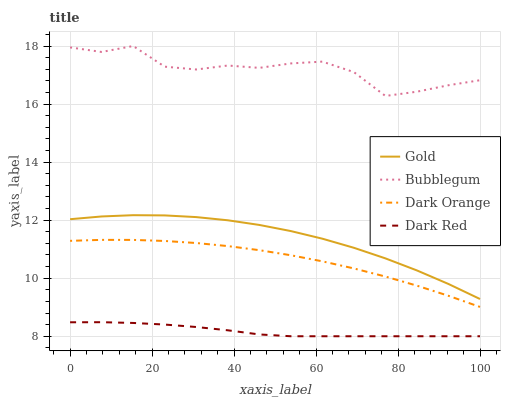Does Dark Red have the minimum area under the curve?
Answer yes or no. Yes. Does Bubblegum have the maximum area under the curve?
Answer yes or no. Yes. Does Gold have the minimum area under the curve?
Answer yes or no. No. Does Gold have the maximum area under the curve?
Answer yes or no. No. Is Dark Red the smoothest?
Answer yes or no. Yes. Is Bubblegum the roughest?
Answer yes or no. Yes. Is Gold the smoothest?
Answer yes or no. No. Is Gold the roughest?
Answer yes or no. No. Does Dark Red have the lowest value?
Answer yes or no. Yes. Does Gold have the lowest value?
Answer yes or no. No. Does Bubblegum have the highest value?
Answer yes or no. Yes. Does Gold have the highest value?
Answer yes or no. No. Is Gold less than Bubblegum?
Answer yes or no. Yes. Is Dark Orange greater than Dark Red?
Answer yes or no. Yes. Does Gold intersect Bubblegum?
Answer yes or no. No. 